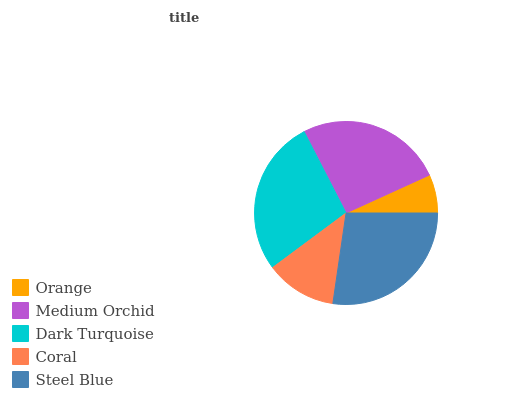Is Orange the minimum?
Answer yes or no. Yes. Is Dark Turquoise the maximum?
Answer yes or no. Yes. Is Medium Orchid the minimum?
Answer yes or no. No. Is Medium Orchid the maximum?
Answer yes or no. No. Is Medium Orchid greater than Orange?
Answer yes or no. Yes. Is Orange less than Medium Orchid?
Answer yes or no. Yes. Is Orange greater than Medium Orchid?
Answer yes or no. No. Is Medium Orchid less than Orange?
Answer yes or no. No. Is Medium Orchid the high median?
Answer yes or no. Yes. Is Medium Orchid the low median?
Answer yes or no. Yes. Is Dark Turquoise the high median?
Answer yes or no. No. Is Orange the low median?
Answer yes or no. No. 